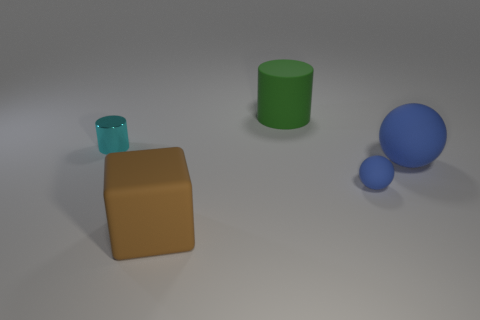What kind of setting or environment does this image suggest? The image suggests a simple, controlled environment, possibly a studio or an indoor setting used for visualization or testing purposes, due to the plain background and soft shadows. 